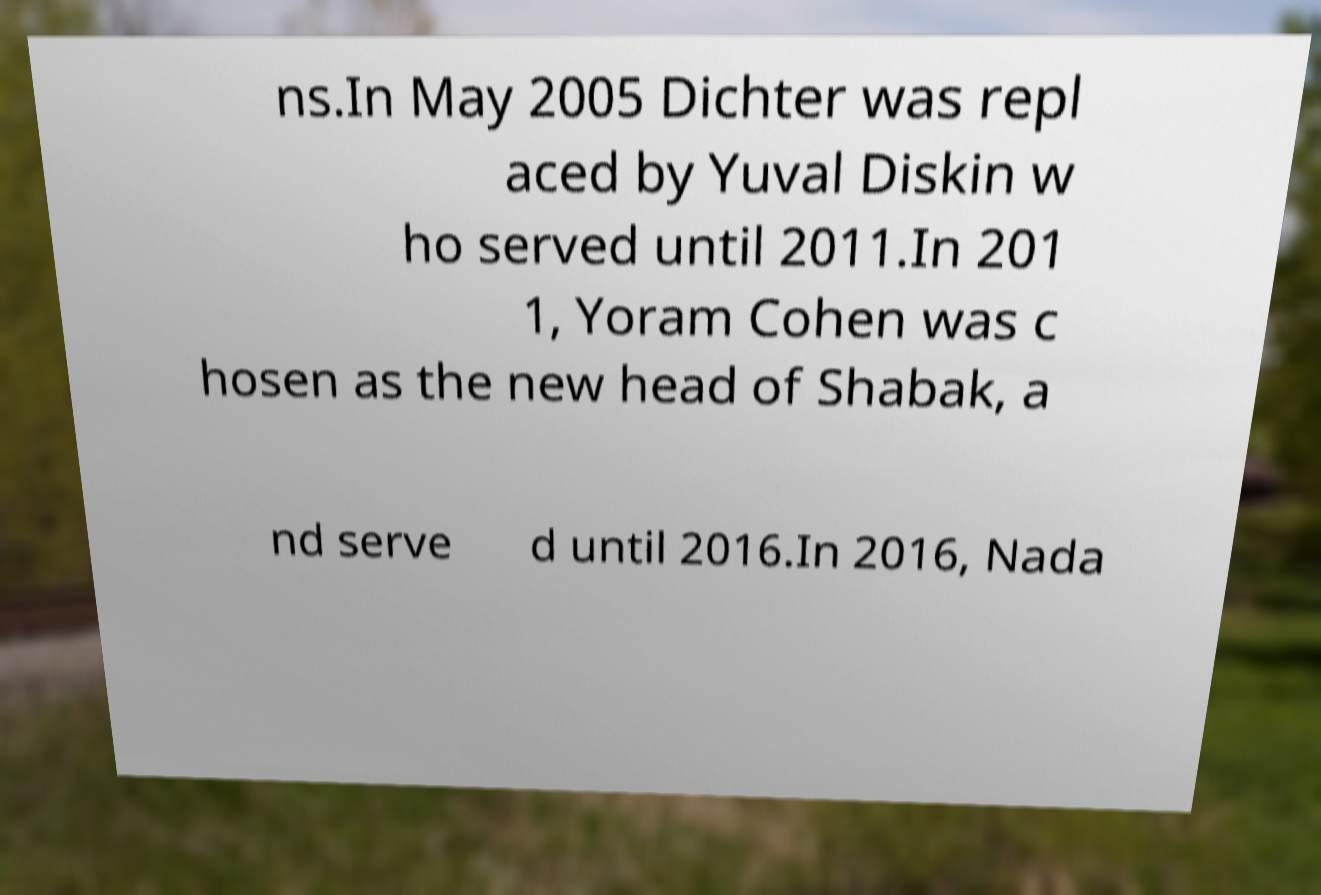For documentation purposes, I need the text within this image transcribed. Could you provide that? ns.In May 2005 Dichter was repl aced by Yuval Diskin w ho served until 2011.In 201 1, Yoram Cohen was c hosen as the new head of Shabak, a nd serve d until 2016.In 2016, Nada 